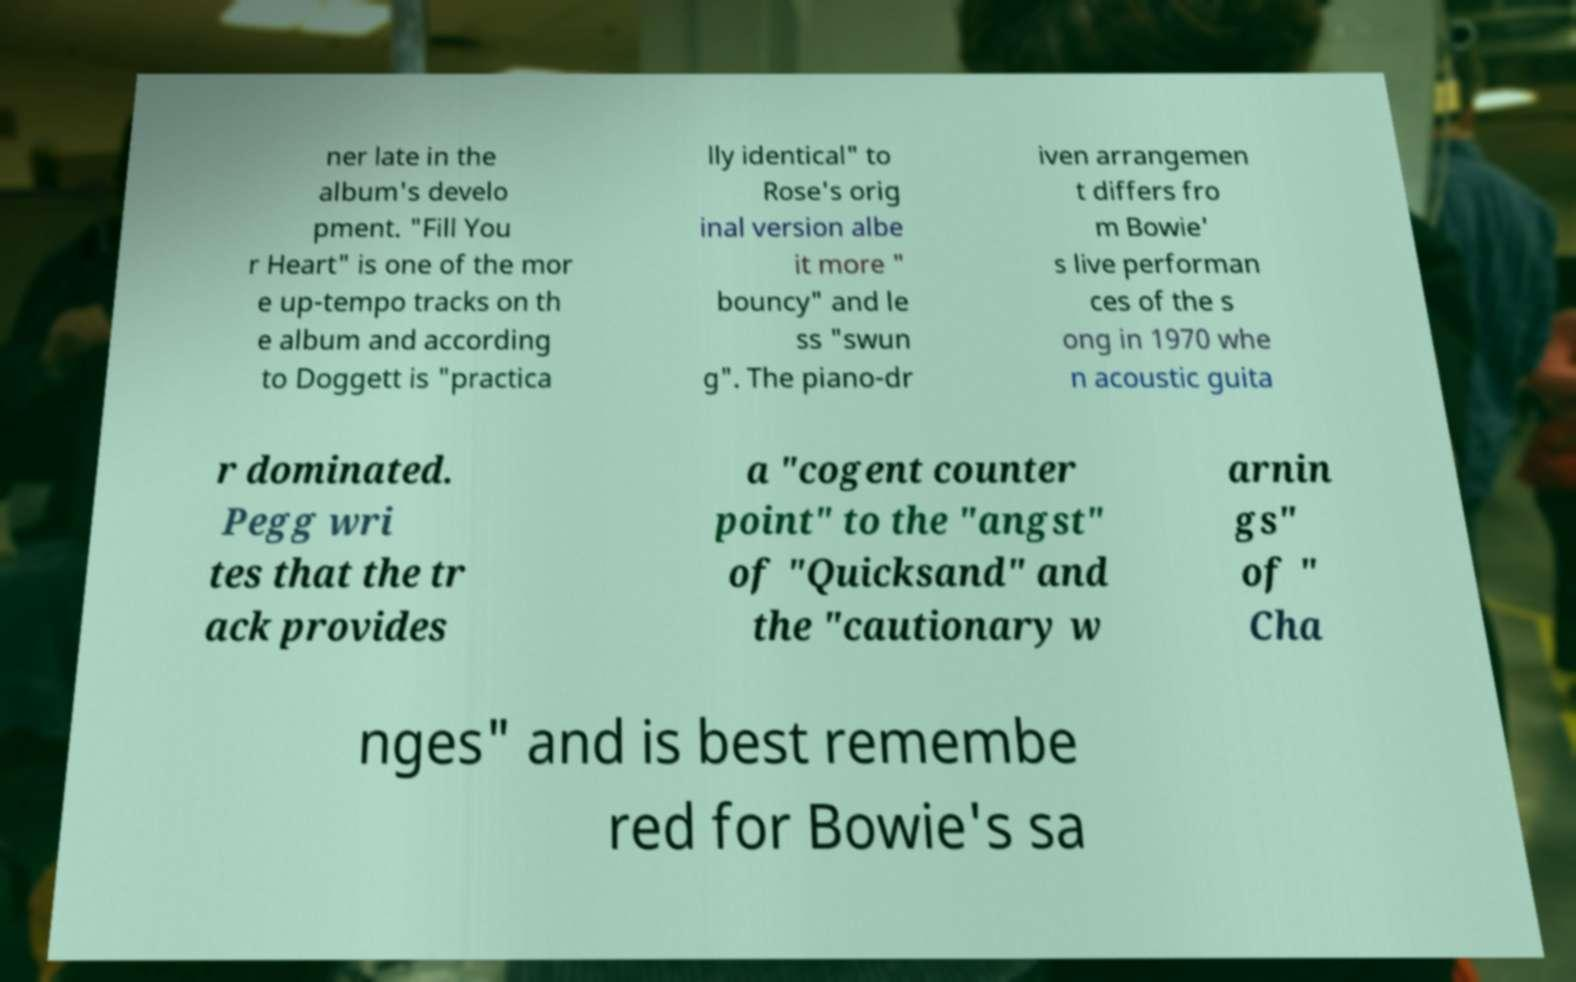Can you read and provide the text displayed in the image?This photo seems to have some interesting text. Can you extract and type it out for me? ner late in the album's develo pment. "Fill You r Heart" is one of the mor e up-tempo tracks on th e album and according to Doggett is "practica lly identical" to Rose's orig inal version albe it more " bouncy" and le ss "swun g". The piano-dr iven arrangemen t differs fro m Bowie' s live performan ces of the s ong in 1970 whe n acoustic guita r dominated. Pegg wri tes that the tr ack provides a "cogent counter point" to the "angst" of "Quicksand" and the "cautionary w arnin gs" of " Cha nges" and is best remembe red for Bowie's sa 